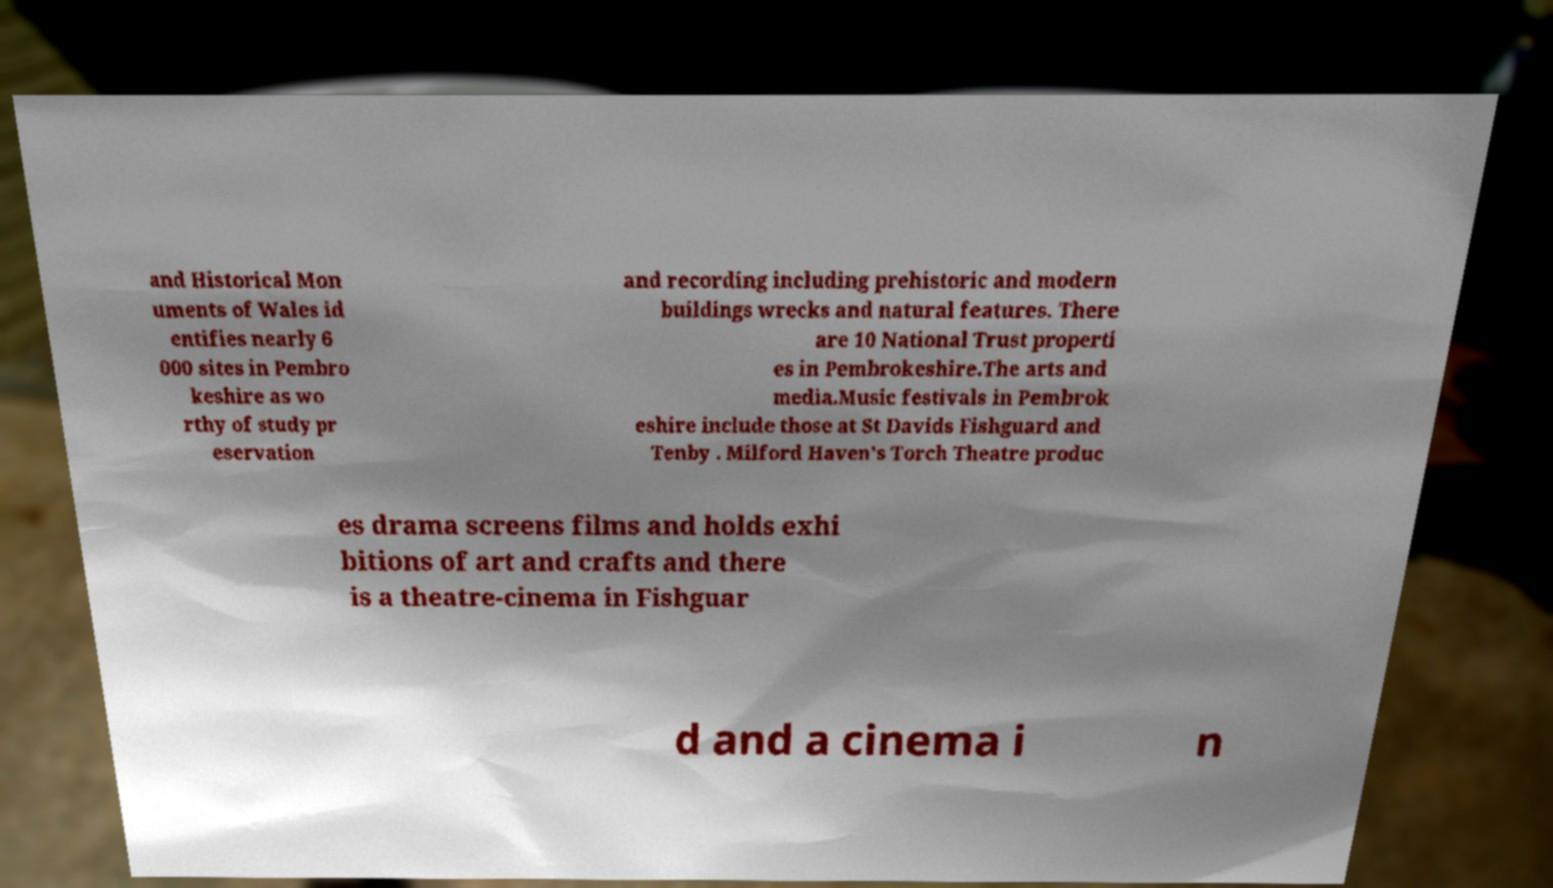What messages or text are displayed in this image? I need them in a readable, typed format. and Historical Mon uments of Wales id entifies nearly 6 000 sites in Pembro keshire as wo rthy of study pr eservation and recording including prehistoric and modern buildings wrecks and natural features. There are 10 National Trust properti es in Pembrokeshire.The arts and media.Music festivals in Pembrok eshire include those at St Davids Fishguard and Tenby . Milford Haven's Torch Theatre produc es drama screens films and holds exhi bitions of art and crafts and there is a theatre-cinema in Fishguar d and a cinema i n 